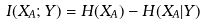Convert formula to latex. <formula><loc_0><loc_0><loc_500><loc_500>I ( X _ { A } ; Y ) = H ( X _ { A } ) - H ( X _ { A } | Y )</formula> 